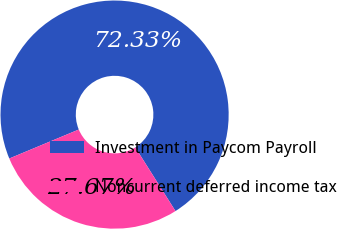Convert chart to OTSL. <chart><loc_0><loc_0><loc_500><loc_500><pie_chart><fcel>Investment in Paycom Payroll<fcel>Noncurrent deferred income tax<nl><fcel>72.33%<fcel>27.67%<nl></chart> 